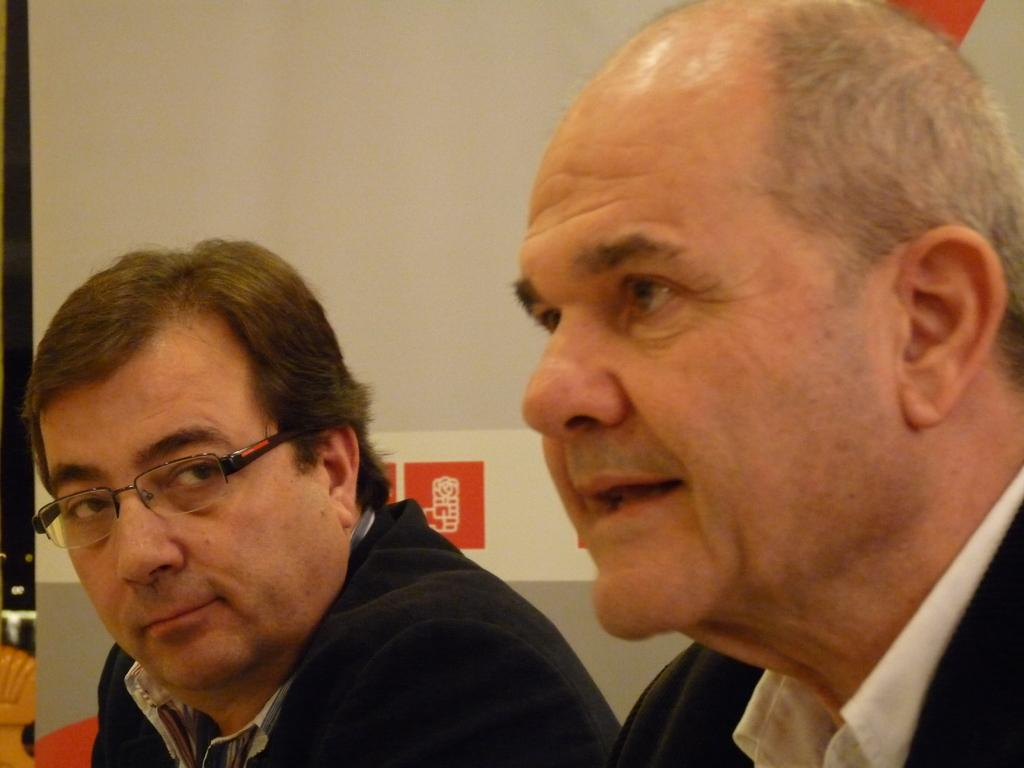How many people are in the image? There are two men in the image. Can you describe one of the men's appearance? One of the men is wearing spectacles. What can be seen in the background of the image? There is a wall in the background of the image. Can you tell me what type of fruit is hanging from the wall in the image? There is no fruit hanging from the wall in the image; it only features two men and a wall in the background. 